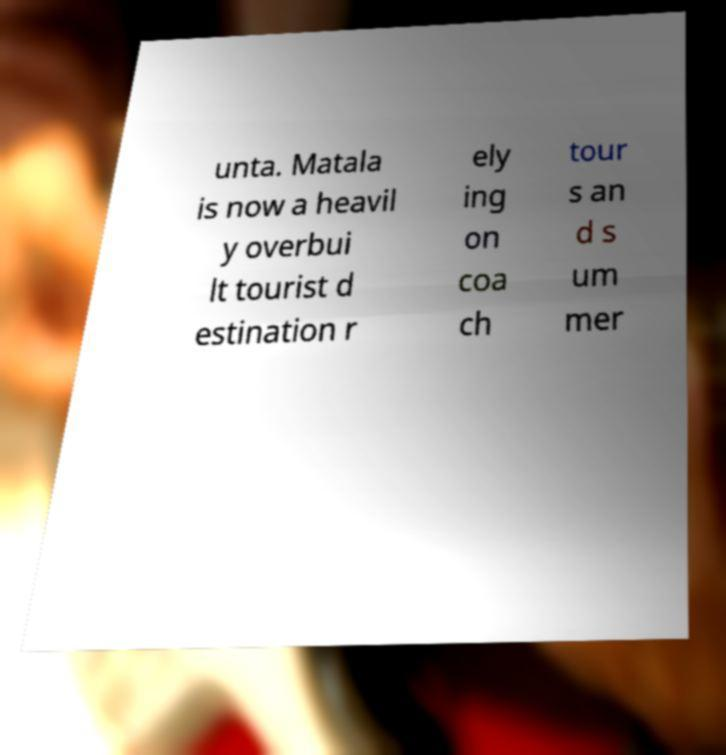I need the written content from this picture converted into text. Can you do that? unta. Matala is now a heavil y overbui lt tourist d estination r ely ing on coa ch tour s an d s um mer 